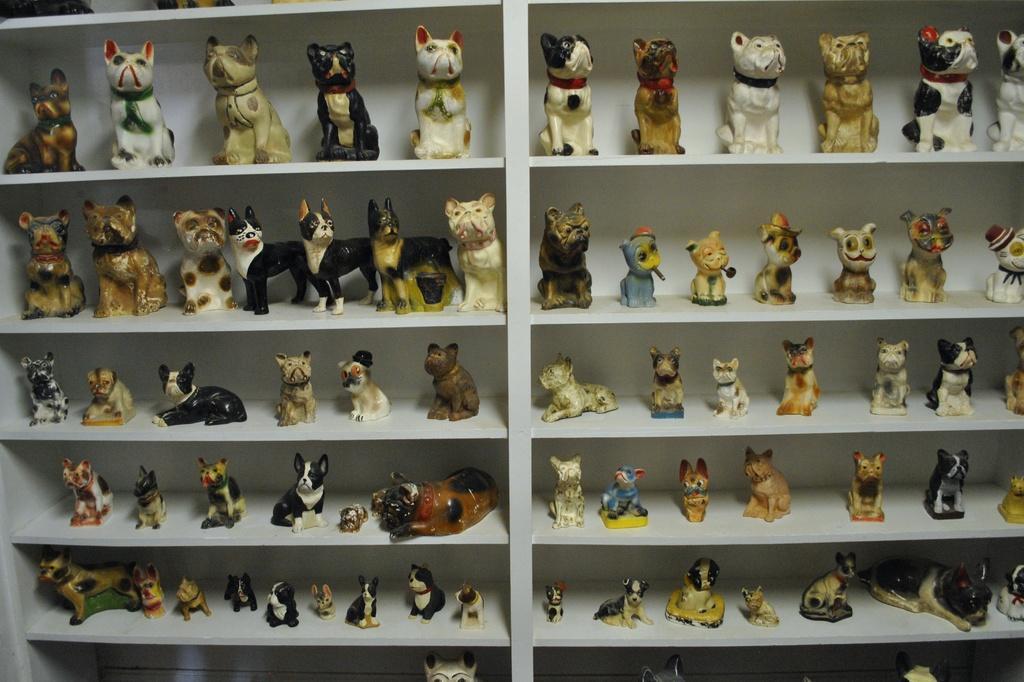Describe this image in one or two sentences. This image consists of many toys of dogs and cats are kept in a rack. 